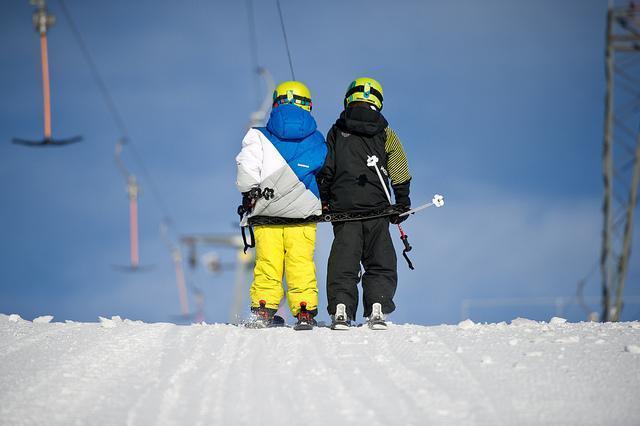How many people are there?
Give a very brief answer. 2. 